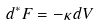<formula> <loc_0><loc_0><loc_500><loc_500>d ^ { * } F = - \kappa \, d V</formula> 